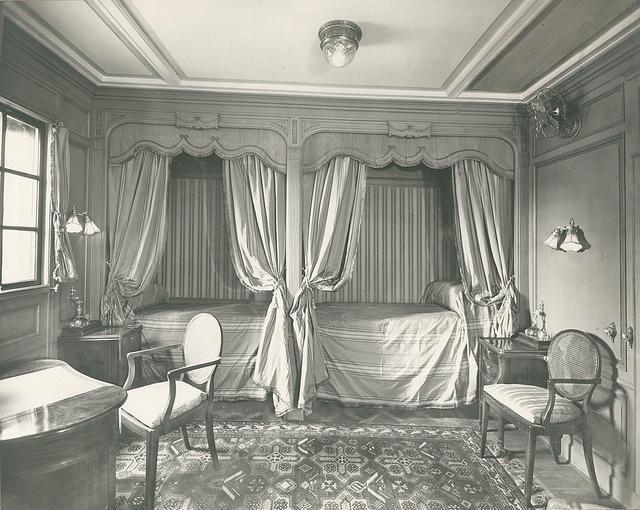How many beds are there?
Give a very brief answer. 2. How many chairs are there?
Give a very brief answer. 2. 